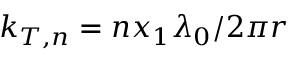Convert formula to latex. <formula><loc_0><loc_0><loc_500><loc_500>k _ { T , n } = n x _ { 1 } \lambda _ { 0 } / 2 \pi r</formula> 